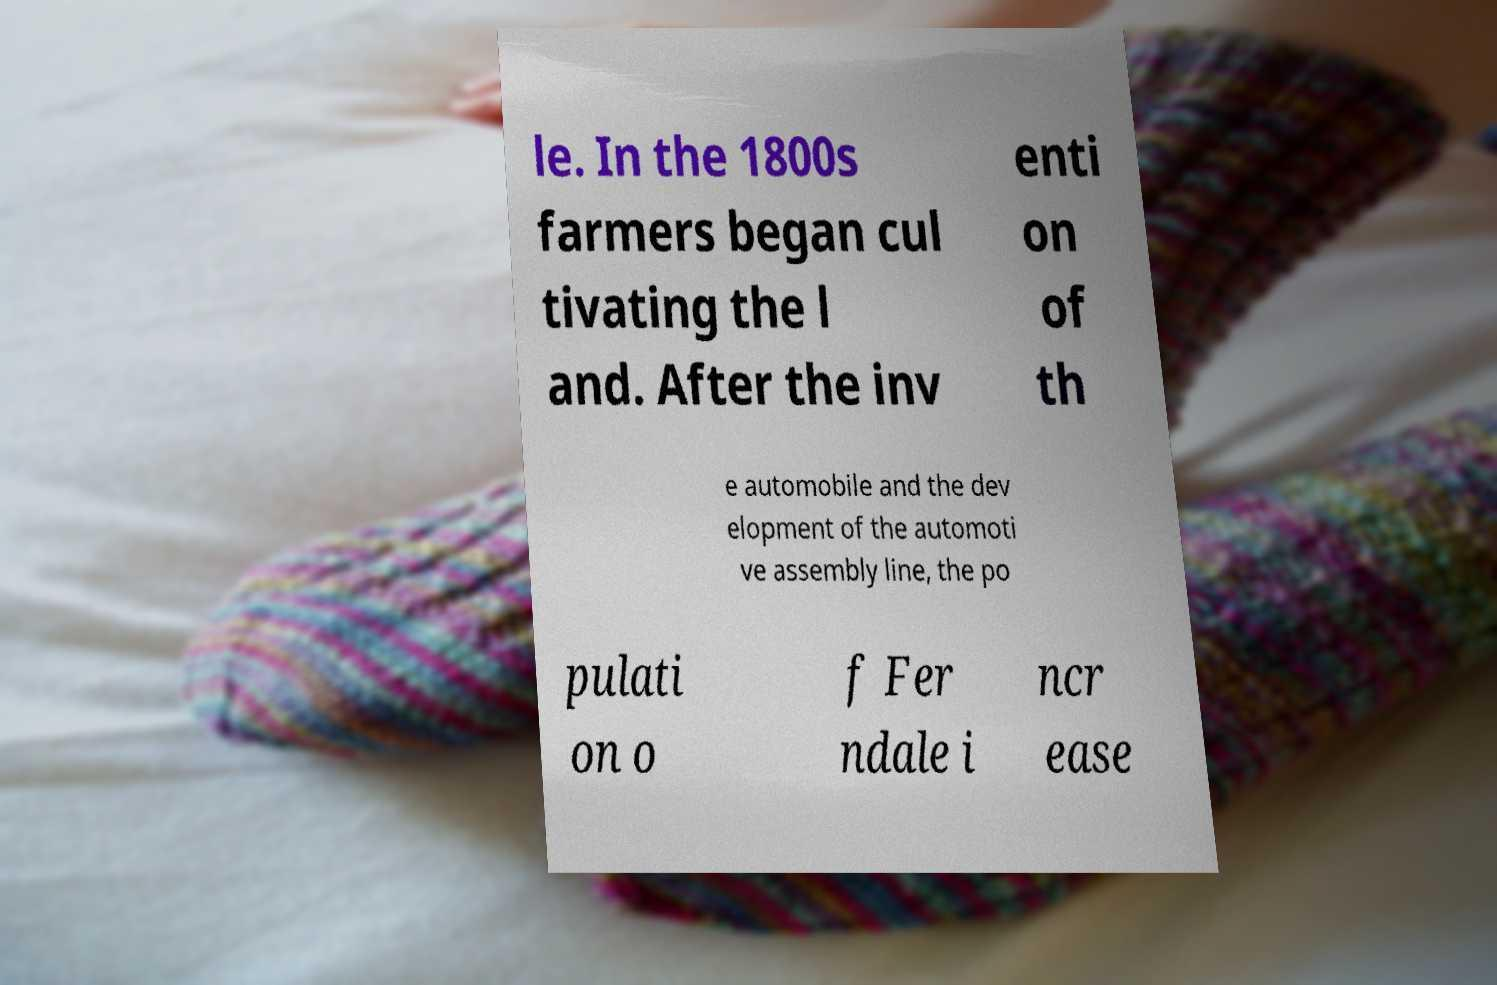Could you assist in decoding the text presented in this image and type it out clearly? le. In the 1800s farmers began cul tivating the l and. After the inv enti on of th e automobile and the dev elopment of the automoti ve assembly line, the po pulati on o f Fer ndale i ncr ease 